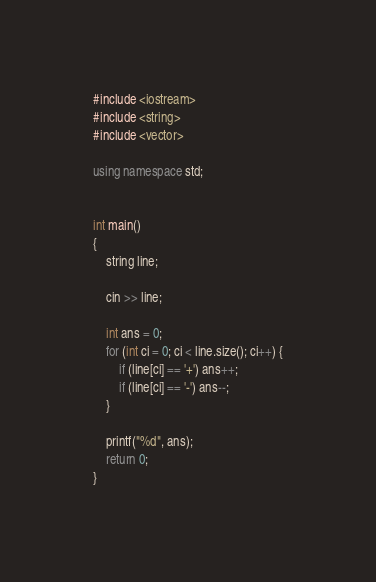Convert code to text. <code><loc_0><loc_0><loc_500><loc_500><_C++_>
#include <iostream>
#include <string>
#include <vector>

using namespace std;


int main()
{
	string line;

	cin >> line;

	int ans = 0;
	for (int ci = 0; ci < line.size(); ci++) {
		if (line[ci] == '+') ans++;
		if (line[ci] == '-') ans--;
	}

	printf("%d", ans);
	return 0;
}

</code> 